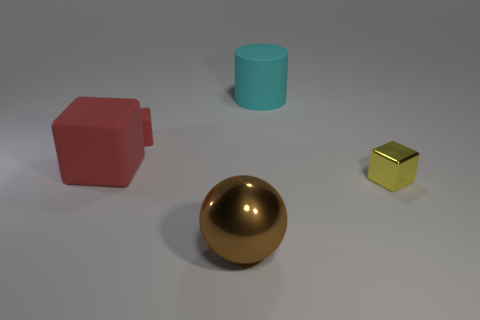The shiny object that is to the left of the big matte object to the right of the shiny thing to the left of the tiny yellow object is what shape?
Keep it short and to the point. Sphere. The big rubber object that is the same shape as the small red matte object is what color?
Provide a succinct answer. Red. There is a matte object that is both behind the big red matte object and to the left of the cyan rubber cylinder; what size is it?
Offer a terse response. Small. How many small things are on the right side of the object that is in front of the metallic object to the right of the large cyan cylinder?
Offer a very short reply. 1. What number of big objects are either metallic balls or red things?
Your response must be concise. 2. Are the small block left of the large cylinder and the big cyan cylinder made of the same material?
Offer a terse response. Yes. The small cube that is right of the shiny object that is in front of the tiny thing that is on the right side of the brown metal object is made of what material?
Offer a terse response. Metal. Is there any other thing that has the same size as the cyan matte object?
Make the answer very short. Yes. How many matte objects are either big objects or big brown objects?
Provide a succinct answer. 2. Are there any tiny brown shiny cylinders?
Your answer should be compact. No. 